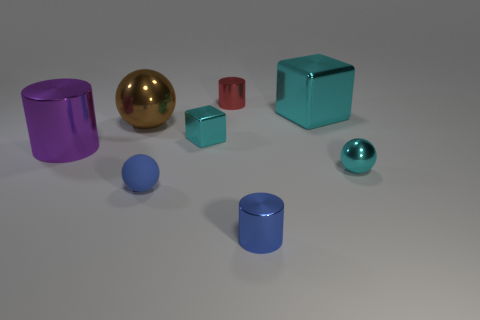What number of other objects are the same size as the red object?
Your answer should be very brief. 4. What number of objects are either small shiny spheres that are right of the blue rubber thing or metallic balls that are to the right of the small blue rubber sphere?
Provide a succinct answer. 1. What number of brown shiny things are the same shape as the tiny red metallic thing?
Make the answer very short. 0. What material is the sphere that is both in front of the purple thing and on the left side of the big cyan cube?
Your answer should be compact. Rubber. There is a small red thing; how many big purple shiny things are behind it?
Ensure brevity in your answer.  0. How many blue balls are there?
Offer a terse response. 1. Do the cyan ball and the purple thing have the same size?
Offer a very short reply. No. Are there any big blocks on the right side of the cyan thing that is left of the tiny metal cylinder that is behind the blue cylinder?
Your answer should be compact. Yes. There is another small object that is the same shape as the red metallic object; what material is it?
Offer a terse response. Metal. What is the color of the big metallic object to the right of the tiny cyan block?
Your answer should be very brief. Cyan. 